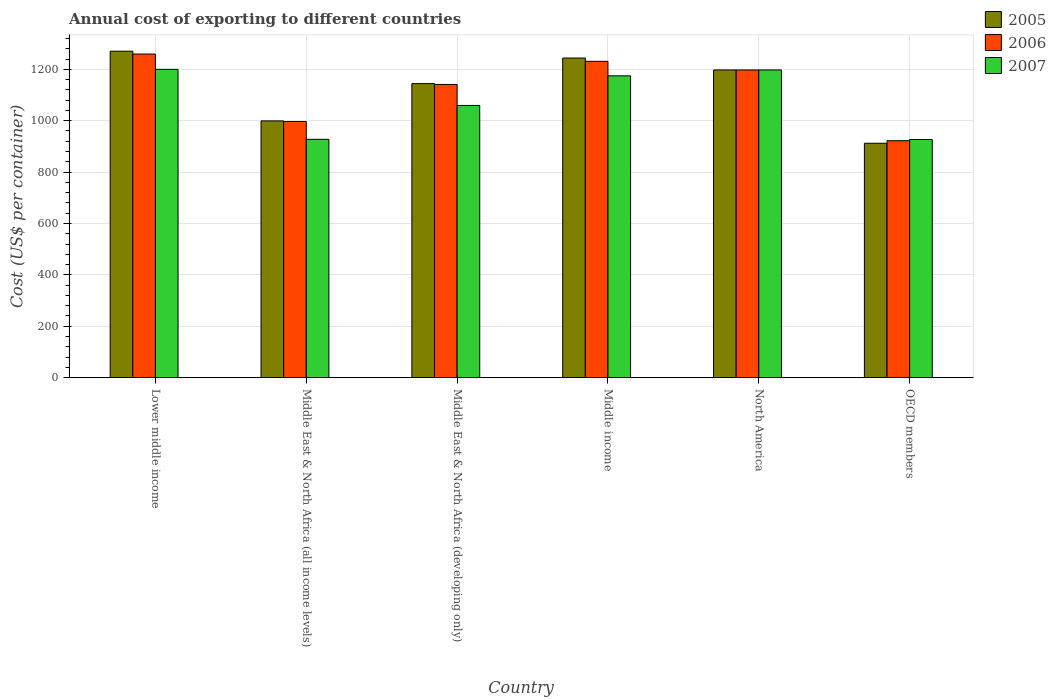How many different coloured bars are there?
Provide a succinct answer. 3. How many groups of bars are there?
Provide a succinct answer. 6. How many bars are there on the 3rd tick from the left?
Offer a terse response. 3. How many bars are there on the 4th tick from the right?
Your response must be concise. 3. In how many cases, is the number of bars for a given country not equal to the number of legend labels?
Your response must be concise. 0. What is the total annual cost of exporting in 2005 in Lower middle income?
Your response must be concise. 1270.47. Across all countries, what is the maximum total annual cost of exporting in 2005?
Your response must be concise. 1270.47. Across all countries, what is the minimum total annual cost of exporting in 2005?
Ensure brevity in your answer.  912.18. In which country was the total annual cost of exporting in 2007 maximum?
Give a very brief answer. Lower middle income. In which country was the total annual cost of exporting in 2007 minimum?
Ensure brevity in your answer.  OECD members. What is the total total annual cost of exporting in 2006 in the graph?
Ensure brevity in your answer.  6748. What is the difference between the total annual cost of exporting in 2006 in Middle East & North Africa (all income levels) and that in OECD members?
Give a very brief answer. 74.76. What is the difference between the total annual cost of exporting in 2006 in OECD members and the total annual cost of exporting in 2007 in Middle East & North Africa (developing only)?
Make the answer very short. -137.22. What is the average total annual cost of exporting in 2007 per country?
Offer a very short reply. 1080.92. What is the difference between the total annual cost of exporting of/in 2006 and total annual cost of exporting of/in 2005 in Middle income?
Make the answer very short. -12.79. What is the ratio of the total annual cost of exporting in 2007 in Lower middle income to that in North America?
Offer a terse response. 1. Is the difference between the total annual cost of exporting in 2006 in Middle East & North Africa (all income levels) and OECD members greater than the difference between the total annual cost of exporting in 2005 in Middle East & North Africa (all income levels) and OECD members?
Keep it short and to the point. No. What is the difference between the highest and the second highest total annual cost of exporting in 2005?
Offer a terse response. 46.39. What is the difference between the highest and the lowest total annual cost of exporting in 2007?
Ensure brevity in your answer.  273.06. Is the sum of the total annual cost of exporting in 2005 in Middle income and North America greater than the maximum total annual cost of exporting in 2006 across all countries?
Make the answer very short. Yes. What does the 2nd bar from the left in Lower middle income represents?
Offer a terse response. 2006. Is it the case that in every country, the sum of the total annual cost of exporting in 2007 and total annual cost of exporting in 2005 is greater than the total annual cost of exporting in 2006?
Ensure brevity in your answer.  Yes. How many bars are there?
Ensure brevity in your answer.  18. What is the difference between two consecutive major ticks on the Y-axis?
Your answer should be very brief. 200. Are the values on the major ticks of Y-axis written in scientific E-notation?
Your answer should be very brief. No. Does the graph contain any zero values?
Keep it short and to the point. No. Does the graph contain grids?
Provide a short and direct response. Yes. How are the legend labels stacked?
Make the answer very short. Vertical. What is the title of the graph?
Your answer should be very brief. Annual cost of exporting to different countries. Does "2011" appear as one of the legend labels in the graph?
Provide a succinct answer. No. What is the label or title of the Y-axis?
Offer a very short reply. Cost (US$ per container). What is the Cost (US$ per container) in 2005 in Lower middle income?
Provide a short and direct response. 1270.47. What is the Cost (US$ per container) of 2006 in Lower middle income?
Ensure brevity in your answer.  1259.41. What is the Cost (US$ per container) of 2007 in Lower middle income?
Make the answer very short. 1199.8. What is the Cost (US$ per container) in 2005 in Middle East & North Africa (all income levels)?
Give a very brief answer. 999.24. What is the Cost (US$ per container) of 2006 in Middle East & North Africa (all income levels)?
Your answer should be compact. 996.88. What is the Cost (US$ per container) in 2007 in Middle East & North Africa (all income levels)?
Give a very brief answer. 927.58. What is the Cost (US$ per container) in 2005 in Middle East & North Africa (developing only)?
Give a very brief answer. 1144.33. What is the Cost (US$ per container) in 2006 in Middle East & North Africa (developing only)?
Offer a terse response. 1141. What is the Cost (US$ per container) of 2007 in Middle East & North Africa (developing only)?
Your answer should be very brief. 1059.33. What is the Cost (US$ per container) in 2005 in Middle income?
Your answer should be very brief. 1243.89. What is the Cost (US$ per container) of 2006 in Middle income?
Keep it short and to the point. 1231.09. What is the Cost (US$ per container) of 2007 in Middle income?
Offer a terse response. 1174.6. What is the Cost (US$ per container) in 2005 in North America?
Provide a short and direct response. 1197.5. What is the Cost (US$ per container) of 2006 in North America?
Make the answer very short. 1197.5. What is the Cost (US$ per container) in 2007 in North America?
Keep it short and to the point. 1197.5. What is the Cost (US$ per container) of 2005 in OECD members?
Your answer should be compact. 912.18. What is the Cost (US$ per container) of 2006 in OECD members?
Your answer should be compact. 922.12. What is the Cost (US$ per container) in 2007 in OECD members?
Ensure brevity in your answer.  926.74. Across all countries, what is the maximum Cost (US$ per container) of 2005?
Your answer should be compact. 1270.47. Across all countries, what is the maximum Cost (US$ per container) of 2006?
Give a very brief answer. 1259.41. Across all countries, what is the maximum Cost (US$ per container) in 2007?
Your answer should be very brief. 1199.8. Across all countries, what is the minimum Cost (US$ per container) in 2005?
Your response must be concise. 912.18. Across all countries, what is the minimum Cost (US$ per container) in 2006?
Your answer should be compact. 922.12. Across all countries, what is the minimum Cost (US$ per container) of 2007?
Your answer should be compact. 926.74. What is the total Cost (US$ per container) of 2005 in the graph?
Your answer should be very brief. 6767.61. What is the total Cost (US$ per container) of 2006 in the graph?
Your answer should be very brief. 6748. What is the total Cost (US$ per container) of 2007 in the graph?
Give a very brief answer. 6485.54. What is the difference between the Cost (US$ per container) in 2005 in Lower middle income and that in Middle East & North Africa (all income levels)?
Give a very brief answer. 271.23. What is the difference between the Cost (US$ per container) in 2006 in Lower middle income and that in Middle East & North Africa (all income levels)?
Offer a terse response. 262.53. What is the difference between the Cost (US$ per container) in 2007 in Lower middle income and that in Middle East & North Africa (all income levels)?
Keep it short and to the point. 272.22. What is the difference between the Cost (US$ per container) of 2005 in Lower middle income and that in Middle East & North Africa (developing only)?
Ensure brevity in your answer.  126.14. What is the difference between the Cost (US$ per container) in 2006 in Lower middle income and that in Middle East & North Africa (developing only)?
Ensure brevity in your answer.  118.41. What is the difference between the Cost (US$ per container) of 2007 in Lower middle income and that in Middle East & North Africa (developing only)?
Your response must be concise. 140.46. What is the difference between the Cost (US$ per container) of 2005 in Lower middle income and that in Middle income?
Give a very brief answer. 26.58. What is the difference between the Cost (US$ per container) of 2006 in Lower middle income and that in Middle income?
Ensure brevity in your answer.  28.32. What is the difference between the Cost (US$ per container) in 2007 in Lower middle income and that in Middle income?
Offer a very short reply. 25.2. What is the difference between the Cost (US$ per container) in 2005 in Lower middle income and that in North America?
Provide a short and direct response. 72.97. What is the difference between the Cost (US$ per container) of 2006 in Lower middle income and that in North America?
Your response must be concise. 61.91. What is the difference between the Cost (US$ per container) of 2007 in Lower middle income and that in North America?
Ensure brevity in your answer.  2.3. What is the difference between the Cost (US$ per container) in 2005 in Lower middle income and that in OECD members?
Provide a succinct answer. 358.29. What is the difference between the Cost (US$ per container) of 2006 in Lower middle income and that in OECD members?
Your answer should be very brief. 337.29. What is the difference between the Cost (US$ per container) of 2007 in Lower middle income and that in OECD members?
Provide a short and direct response. 273.06. What is the difference between the Cost (US$ per container) in 2005 in Middle East & North Africa (all income levels) and that in Middle East & North Africa (developing only)?
Keep it short and to the point. -145.1. What is the difference between the Cost (US$ per container) of 2006 in Middle East & North Africa (all income levels) and that in Middle East & North Africa (developing only)?
Make the answer very short. -144.12. What is the difference between the Cost (US$ per container) of 2007 in Middle East & North Africa (all income levels) and that in Middle East & North Africa (developing only)?
Your answer should be very brief. -131.75. What is the difference between the Cost (US$ per container) of 2005 in Middle East & North Africa (all income levels) and that in Middle income?
Provide a succinct answer. -244.65. What is the difference between the Cost (US$ per container) of 2006 in Middle East & North Africa (all income levels) and that in Middle income?
Offer a very short reply. -234.21. What is the difference between the Cost (US$ per container) in 2007 in Middle East & North Africa (all income levels) and that in Middle income?
Your answer should be compact. -247.02. What is the difference between the Cost (US$ per container) of 2005 in Middle East & North Africa (all income levels) and that in North America?
Ensure brevity in your answer.  -198.26. What is the difference between the Cost (US$ per container) of 2006 in Middle East & North Africa (all income levels) and that in North America?
Provide a short and direct response. -200.62. What is the difference between the Cost (US$ per container) of 2007 in Middle East & North Africa (all income levels) and that in North America?
Give a very brief answer. -269.92. What is the difference between the Cost (US$ per container) of 2005 in Middle East & North Africa (all income levels) and that in OECD members?
Keep it short and to the point. 87.05. What is the difference between the Cost (US$ per container) of 2006 in Middle East & North Africa (all income levels) and that in OECD members?
Ensure brevity in your answer.  74.76. What is the difference between the Cost (US$ per container) in 2007 in Middle East & North Africa (all income levels) and that in OECD members?
Offer a very short reply. 0.84. What is the difference between the Cost (US$ per container) in 2005 in Middle East & North Africa (developing only) and that in Middle income?
Offer a terse response. -99.55. What is the difference between the Cost (US$ per container) in 2006 in Middle East & North Africa (developing only) and that in Middle income?
Provide a succinct answer. -90.09. What is the difference between the Cost (US$ per container) of 2007 in Middle East & North Africa (developing only) and that in Middle income?
Keep it short and to the point. -115.26. What is the difference between the Cost (US$ per container) of 2005 in Middle East & North Africa (developing only) and that in North America?
Provide a succinct answer. -53.17. What is the difference between the Cost (US$ per container) in 2006 in Middle East & North Africa (developing only) and that in North America?
Your answer should be very brief. -56.5. What is the difference between the Cost (US$ per container) of 2007 in Middle East & North Africa (developing only) and that in North America?
Offer a very short reply. -138.17. What is the difference between the Cost (US$ per container) in 2005 in Middle East & North Africa (developing only) and that in OECD members?
Your answer should be compact. 232.15. What is the difference between the Cost (US$ per container) of 2006 in Middle East & North Africa (developing only) and that in OECD members?
Your answer should be compact. 218.88. What is the difference between the Cost (US$ per container) of 2007 in Middle East & North Africa (developing only) and that in OECD members?
Offer a terse response. 132.6. What is the difference between the Cost (US$ per container) of 2005 in Middle income and that in North America?
Offer a terse response. 46.39. What is the difference between the Cost (US$ per container) in 2006 in Middle income and that in North America?
Make the answer very short. 33.59. What is the difference between the Cost (US$ per container) of 2007 in Middle income and that in North America?
Provide a succinct answer. -22.9. What is the difference between the Cost (US$ per container) of 2005 in Middle income and that in OECD members?
Make the answer very short. 331.7. What is the difference between the Cost (US$ per container) in 2006 in Middle income and that in OECD members?
Provide a succinct answer. 308.98. What is the difference between the Cost (US$ per container) of 2007 in Middle income and that in OECD members?
Offer a very short reply. 247.86. What is the difference between the Cost (US$ per container) of 2005 in North America and that in OECD members?
Ensure brevity in your answer.  285.32. What is the difference between the Cost (US$ per container) of 2006 in North America and that in OECD members?
Ensure brevity in your answer.  275.38. What is the difference between the Cost (US$ per container) in 2007 in North America and that in OECD members?
Provide a succinct answer. 270.76. What is the difference between the Cost (US$ per container) of 2005 in Lower middle income and the Cost (US$ per container) of 2006 in Middle East & North Africa (all income levels)?
Ensure brevity in your answer.  273.59. What is the difference between the Cost (US$ per container) in 2005 in Lower middle income and the Cost (US$ per container) in 2007 in Middle East & North Africa (all income levels)?
Keep it short and to the point. 342.89. What is the difference between the Cost (US$ per container) in 2006 in Lower middle income and the Cost (US$ per container) in 2007 in Middle East & North Africa (all income levels)?
Provide a short and direct response. 331.83. What is the difference between the Cost (US$ per container) of 2005 in Lower middle income and the Cost (US$ per container) of 2006 in Middle East & North Africa (developing only)?
Provide a succinct answer. 129.47. What is the difference between the Cost (US$ per container) in 2005 in Lower middle income and the Cost (US$ per container) in 2007 in Middle East & North Africa (developing only)?
Give a very brief answer. 211.14. What is the difference between the Cost (US$ per container) of 2006 in Lower middle income and the Cost (US$ per container) of 2007 in Middle East & North Africa (developing only)?
Provide a succinct answer. 200.07. What is the difference between the Cost (US$ per container) of 2005 in Lower middle income and the Cost (US$ per container) of 2006 in Middle income?
Ensure brevity in your answer.  39.38. What is the difference between the Cost (US$ per container) in 2005 in Lower middle income and the Cost (US$ per container) in 2007 in Middle income?
Your answer should be compact. 95.87. What is the difference between the Cost (US$ per container) in 2006 in Lower middle income and the Cost (US$ per container) in 2007 in Middle income?
Offer a terse response. 84.81. What is the difference between the Cost (US$ per container) in 2005 in Lower middle income and the Cost (US$ per container) in 2006 in North America?
Make the answer very short. 72.97. What is the difference between the Cost (US$ per container) of 2005 in Lower middle income and the Cost (US$ per container) of 2007 in North America?
Provide a succinct answer. 72.97. What is the difference between the Cost (US$ per container) in 2006 in Lower middle income and the Cost (US$ per container) in 2007 in North America?
Ensure brevity in your answer.  61.91. What is the difference between the Cost (US$ per container) of 2005 in Lower middle income and the Cost (US$ per container) of 2006 in OECD members?
Your answer should be very brief. 348.35. What is the difference between the Cost (US$ per container) in 2005 in Lower middle income and the Cost (US$ per container) in 2007 in OECD members?
Make the answer very short. 343.73. What is the difference between the Cost (US$ per container) of 2006 in Lower middle income and the Cost (US$ per container) of 2007 in OECD members?
Provide a succinct answer. 332.67. What is the difference between the Cost (US$ per container) of 2005 in Middle East & North Africa (all income levels) and the Cost (US$ per container) of 2006 in Middle East & North Africa (developing only)?
Make the answer very short. -141.76. What is the difference between the Cost (US$ per container) in 2005 in Middle East & North Africa (all income levels) and the Cost (US$ per container) in 2007 in Middle East & North Africa (developing only)?
Provide a succinct answer. -60.1. What is the difference between the Cost (US$ per container) in 2006 in Middle East & North Africa (all income levels) and the Cost (US$ per container) in 2007 in Middle East & North Africa (developing only)?
Offer a very short reply. -62.45. What is the difference between the Cost (US$ per container) of 2005 in Middle East & North Africa (all income levels) and the Cost (US$ per container) of 2006 in Middle income?
Give a very brief answer. -231.86. What is the difference between the Cost (US$ per container) in 2005 in Middle East & North Africa (all income levels) and the Cost (US$ per container) in 2007 in Middle income?
Your answer should be very brief. -175.36. What is the difference between the Cost (US$ per container) of 2006 in Middle East & North Africa (all income levels) and the Cost (US$ per container) of 2007 in Middle income?
Make the answer very short. -177.72. What is the difference between the Cost (US$ per container) of 2005 in Middle East & North Africa (all income levels) and the Cost (US$ per container) of 2006 in North America?
Provide a succinct answer. -198.26. What is the difference between the Cost (US$ per container) in 2005 in Middle East & North Africa (all income levels) and the Cost (US$ per container) in 2007 in North America?
Your answer should be compact. -198.26. What is the difference between the Cost (US$ per container) in 2006 in Middle East & North Africa (all income levels) and the Cost (US$ per container) in 2007 in North America?
Give a very brief answer. -200.62. What is the difference between the Cost (US$ per container) in 2005 in Middle East & North Africa (all income levels) and the Cost (US$ per container) in 2006 in OECD members?
Keep it short and to the point. 77.12. What is the difference between the Cost (US$ per container) of 2005 in Middle East & North Africa (all income levels) and the Cost (US$ per container) of 2007 in OECD members?
Your response must be concise. 72.5. What is the difference between the Cost (US$ per container) in 2006 in Middle East & North Africa (all income levels) and the Cost (US$ per container) in 2007 in OECD members?
Offer a terse response. 70.15. What is the difference between the Cost (US$ per container) of 2005 in Middle East & North Africa (developing only) and the Cost (US$ per container) of 2006 in Middle income?
Offer a terse response. -86.76. What is the difference between the Cost (US$ per container) in 2005 in Middle East & North Africa (developing only) and the Cost (US$ per container) in 2007 in Middle income?
Give a very brief answer. -30.26. What is the difference between the Cost (US$ per container) in 2006 in Middle East & North Africa (developing only) and the Cost (US$ per container) in 2007 in Middle income?
Make the answer very short. -33.6. What is the difference between the Cost (US$ per container) in 2005 in Middle East & North Africa (developing only) and the Cost (US$ per container) in 2006 in North America?
Your answer should be compact. -53.17. What is the difference between the Cost (US$ per container) in 2005 in Middle East & North Africa (developing only) and the Cost (US$ per container) in 2007 in North America?
Provide a succinct answer. -53.17. What is the difference between the Cost (US$ per container) in 2006 in Middle East & North Africa (developing only) and the Cost (US$ per container) in 2007 in North America?
Provide a succinct answer. -56.5. What is the difference between the Cost (US$ per container) in 2005 in Middle East & North Africa (developing only) and the Cost (US$ per container) in 2006 in OECD members?
Your answer should be very brief. 222.22. What is the difference between the Cost (US$ per container) in 2005 in Middle East & North Africa (developing only) and the Cost (US$ per container) in 2007 in OECD members?
Your answer should be very brief. 217.6. What is the difference between the Cost (US$ per container) of 2006 in Middle East & North Africa (developing only) and the Cost (US$ per container) of 2007 in OECD members?
Offer a terse response. 214.26. What is the difference between the Cost (US$ per container) in 2005 in Middle income and the Cost (US$ per container) in 2006 in North America?
Provide a short and direct response. 46.39. What is the difference between the Cost (US$ per container) in 2005 in Middle income and the Cost (US$ per container) in 2007 in North America?
Make the answer very short. 46.39. What is the difference between the Cost (US$ per container) of 2006 in Middle income and the Cost (US$ per container) of 2007 in North America?
Ensure brevity in your answer.  33.59. What is the difference between the Cost (US$ per container) of 2005 in Middle income and the Cost (US$ per container) of 2006 in OECD members?
Provide a short and direct response. 321.77. What is the difference between the Cost (US$ per container) of 2005 in Middle income and the Cost (US$ per container) of 2007 in OECD members?
Make the answer very short. 317.15. What is the difference between the Cost (US$ per container) in 2006 in Middle income and the Cost (US$ per container) in 2007 in OECD members?
Your answer should be compact. 304.36. What is the difference between the Cost (US$ per container) in 2005 in North America and the Cost (US$ per container) in 2006 in OECD members?
Your answer should be compact. 275.38. What is the difference between the Cost (US$ per container) of 2005 in North America and the Cost (US$ per container) of 2007 in OECD members?
Offer a terse response. 270.76. What is the difference between the Cost (US$ per container) of 2006 in North America and the Cost (US$ per container) of 2007 in OECD members?
Make the answer very short. 270.76. What is the average Cost (US$ per container) of 2005 per country?
Offer a very short reply. 1127.93. What is the average Cost (US$ per container) in 2006 per country?
Your answer should be very brief. 1124.67. What is the average Cost (US$ per container) in 2007 per country?
Your answer should be very brief. 1080.92. What is the difference between the Cost (US$ per container) of 2005 and Cost (US$ per container) of 2006 in Lower middle income?
Make the answer very short. 11.06. What is the difference between the Cost (US$ per container) of 2005 and Cost (US$ per container) of 2007 in Lower middle income?
Ensure brevity in your answer.  70.67. What is the difference between the Cost (US$ per container) of 2006 and Cost (US$ per container) of 2007 in Lower middle income?
Your answer should be compact. 59.61. What is the difference between the Cost (US$ per container) of 2005 and Cost (US$ per container) of 2006 in Middle East & North Africa (all income levels)?
Keep it short and to the point. 2.35. What is the difference between the Cost (US$ per container) of 2005 and Cost (US$ per container) of 2007 in Middle East & North Africa (all income levels)?
Your answer should be very brief. 71.66. What is the difference between the Cost (US$ per container) of 2006 and Cost (US$ per container) of 2007 in Middle East & North Africa (all income levels)?
Offer a terse response. 69.3. What is the difference between the Cost (US$ per container) in 2005 and Cost (US$ per container) in 2006 in Middle East & North Africa (developing only)?
Provide a short and direct response. 3.33. What is the difference between the Cost (US$ per container) of 2005 and Cost (US$ per container) of 2007 in Middle East & North Africa (developing only)?
Your response must be concise. 85. What is the difference between the Cost (US$ per container) of 2006 and Cost (US$ per container) of 2007 in Middle East & North Africa (developing only)?
Offer a very short reply. 81.67. What is the difference between the Cost (US$ per container) of 2005 and Cost (US$ per container) of 2006 in Middle income?
Make the answer very short. 12.79. What is the difference between the Cost (US$ per container) in 2005 and Cost (US$ per container) in 2007 in Middle income?
Your answer should be very brief. 69.29. What is the difference between the Cost (US$ per container) of 2006 and Cost (US$ per container) of 2007 in Middle income?
Provide a succinct answer. 56.49. What is the difference between the Cost (US$ per container) of 2005 and Cost (US$ per container) of 2007 in North America?
Your response must be concise. 0. What is the difference between the Cost (US$ per container) of 2006 and Cost (US$ per container) of 2007 in North America?
Your answer should be very brief. 0. What is the difference between the Cost (US$ per container) in 2005 and Cost (US$ per container) in 2006 in OECD members?
Ensure brevity in your answer.  -9.94. What is the difference between the Cost (US$ per container) in 2005 and Cost (US$ per container) in 2007 in OECD members?
Keep it short and to the point. -14.55. What is the difference between the Cost (US$ per container) in 2006 and Cost (US$ per container) in 2007 in OECD members?
Offer a terse response. -4.62. What is the ratio of the Cost (US$ per container) of 2005 in Lower middle income to that in Middle East & North Africa (all income levels)?
Provide a short and direct response. 1.27. What is the ratio of the Cost (US$ per container) of 2006 in Lower middle income to that in Middle East & North Africa (all income levels)?
Make the answer very short. 1.26. What is the ratio of the Cost (US$ per container) of 2007 in Lower middle income to that in Middle East & North Africa (all income levels)?
Your answer should be compact. 1.29. What is the ratio of the Cost (US$ per container) of 2005 in Lower middle income to that in Middle East & North Africa (developing only)?
Give a very brief answer. 1.11. What is the ratio of the Cost (US$ per container) of 2006 in Lower middle income to that in Middle East & North Africa (developing only)?
Give a very brief answer. 1.1. What is the ratio of the Cost (US$ per container) of 2007 in Lower middle income to that in Middle East & North Africa (developing only)?
Keep it short and to the point. 1.13. What is the ratio of the Cost (US$ per container) in 2005 in Lower middle income to that in Middle income?
Your answer should be compact. 1.02. What is the ratio of the Cost (US$ per container) of 2007 in Lower middle income to that in Middle income?
Offer a terse response. 1.02. What is the ratio of the Cost (US$ per container) in 2005 in Lower middle income to that in North America?
Provide a succinct answer. 1.06. What is the ratio of the Cost (US$ per container) in 2006 in Lower middle income to that in North America?
Offer a terse response. 1.05. What is the ratio of the Cost (US$ per container) of 2005 in Lower middle income to that in OECD members?
Offer a very short reply. 1.39. What is the ratio of the Cost (US$ per container) in 2006 in Lower middle income to that in OECD members?
Provide a succinct answer. 1.37. What is the ratio of the Cost (US$ per container) of 2007 in Lower middle income to that in OECD members?
Your answer should be very brief. 1.29. What is the ratio of the Cost (US$ per container) of 2005 in Middle East & North Africa (all income levels) to that in Middle East & North Africa (developing only)?
Ensure brevity in your answer.  0.87. What is the ratio of the Cost (US$ per container) in 2006 in Middle East & North Africa (all income levels) to that in Middle East & North Africa (developing only)?
Offer a very short reply. 0.87. What is the ratio of the Cost (US$ per container) of 2007 in Middle East & North Africa (all income levels) to that in Middle East & North Africa (developing only)?
Provide a short and direct response. 0.88. What is the ratio of the Cost (US$ per container) in 2005 in Middle East & North Africa (all income levels) to that in Middle income?
Make the answer very short. 0.8. What is the ratio of the Cost (US$ per container) of 2006 in Middle East & North Africa (all income levels) to that in Middle income?
Provide a succinct answer. 0.81. What is the ratio of the Cost (US$ per container) in 2007 in Middle East & North Africa (all income levels) to that in Middle income?
Give a very brief answer. 0.79. What is the ratio of the Cost (US$ per container) of 2005 in Middle East & North Africa (all income levels) to that in North America?
Offer a very short reply. 0.83. What is the ratio of the Cost (US$ per container) of 2006 in Middle East & North Africa (all income levels) to that in North America?
Your response must be concise. 0.83. What is the ratio of the Cost (US$ per container) in 2007 in Middle East & North Africa (all income levels) to that in North America?
Ensure brevity in your answer.  0.77. What is the ratio of the Cost (US$ per container) of 2005 in Middle East & North Africa (all income levels) to that in OECD members?
Ensure brevity in your answer.  1.1. What is the ratio of the Cost (US$ per container) of 2006 in Middle East & North Africa (all income levels) to that in OECD members?
Offer a terse response. 1.08. What is the ratio of the Cost (US$ per container) of 2005 in Middle East & North Africa (developing only) to that in Middle income?
Offer a terse response. 0.92. What is the ratio of the Cost (US$ per container) in 2006 in Middle East & North Africa (developing only) to that in Middle income?
Offer a very short reply. 0.93. What is the ratio of the Cost (US$ per container) in 2007 in Middle East & North Africa (developing only) to that in Middle income?
Offer a very short reply. 0.9. What is the ratio of the Cost (US$ per container) of 2005 in Middle East & North Africa (developing only) to that in North America?
Offer a terse response. 0.96. What is the ratio of the Cost (US$ per container) in 2006 in Middle East & North Africa (developing only) to that in North America?
Provide a short and direct response. 0.95. What is the ratio of the Cost (US$ per container) of 2007 in Middle East & North Africa (developing only) to that in North America?
Give a very brief answer. 0.88. What is the ratio of the Cost (US$ per container) of 2005 in Middle East & North Africa (developing only) to that in OECD members?
Your answer should be compact. 1.25. What is the ratio of the Cost (US$ per container) in 2006 in Middle East & North Africa (developing only) to that in OECD members?
Your answer should be very brief. 1.24. What is the ratio of the Cost (US$ per container) of 2007 in Middle East & North Africa (developing only) to that in OECD members?
Offer a terse response. 1.14. What is the ratio of the Cost (US$ per container) of 2005 in Middle income to that in North America?
Keep it short and to the point. 1.04. What is the ratio of the Cost (US$ per container) in 2006 in Middle income to that in North America?
Your answer should be very brief. 1.03. What is the ratio of the Cost (US$ per container) in 2007 in Middle income to that in North America?
Provide a short and direct response. 0.98. What is the ratio of the Cost (US$ per container) of 2005 in Middle income to that in OECD members?
Your answer should be compact. 1.36. What is the ratio of the Cost (US$ per container) in 2006 in Middle income to that in OECD members?
Ensure brevity in your answer.  1.34. What is the ratio of the Cost (US$ per container) in 2007 in Middle income to that in OECD members?
Your answer should be compact. 1.27. What is the ratio of the Cost (US$ per container) in 2005 in North America to that in OECD members?
Provide a succinct answer. 1.31. What is the ratio of the Cost (US$ per container) in 2006 in North America to that in OECD members?
Provide a short and direct response. 1.3. What is the ratio of the Cost (US$ per container) of 2007 in North America to that in OECD members?
Offer a terse response. 1.29. What is the difference between the highest and the second highest Cost (US$ per container) in 2005?
Give a very brief answer. 26.58. What is the difference between the highest and the second highest Cost (US$ per container) of 2006?
Your answer should be compact. 28.32. What is the difference between the highest and the second highest Cost (US$ per container) of 2007?
Give a very brief answer. 2.3. What is the difference between the highest and the lowest Cost (US$ per container) in 2005?
Provide a succinct answer. 358.29. What is the difference between the highest and the lowest Cost (US$ per container) of 2006?
Your answer should be very brief. 337.29. What is the difference between the highest and the lowest Cost (US$ per container) of 2007?
Keep it short and to the point. 273.06. 